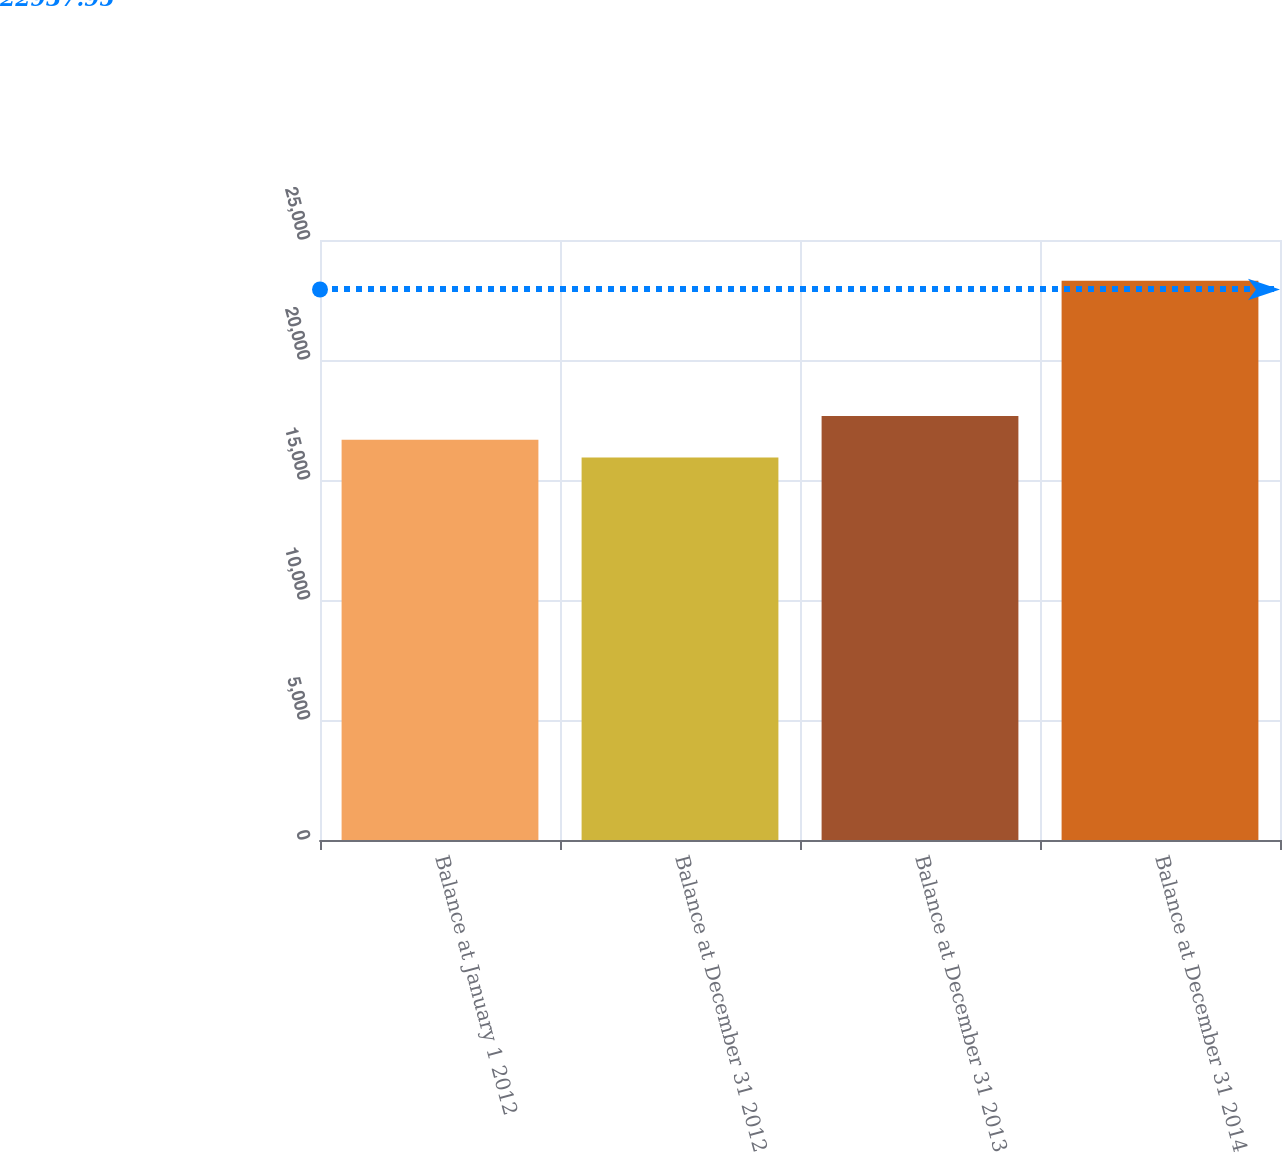Convert chart to OTSL. <chart><loc_0><loc_0><loc_500><loc_500><bar_chart><fcel>Balance at January 1 2012<fcel>Balance at December 31 2012<fcel>Balance at December 31 2013<fcel>Balance at December 31 2014<nl><fcel>16673.1<fcel>15937<fcel>17671<fcel>23298<nl></chart> 